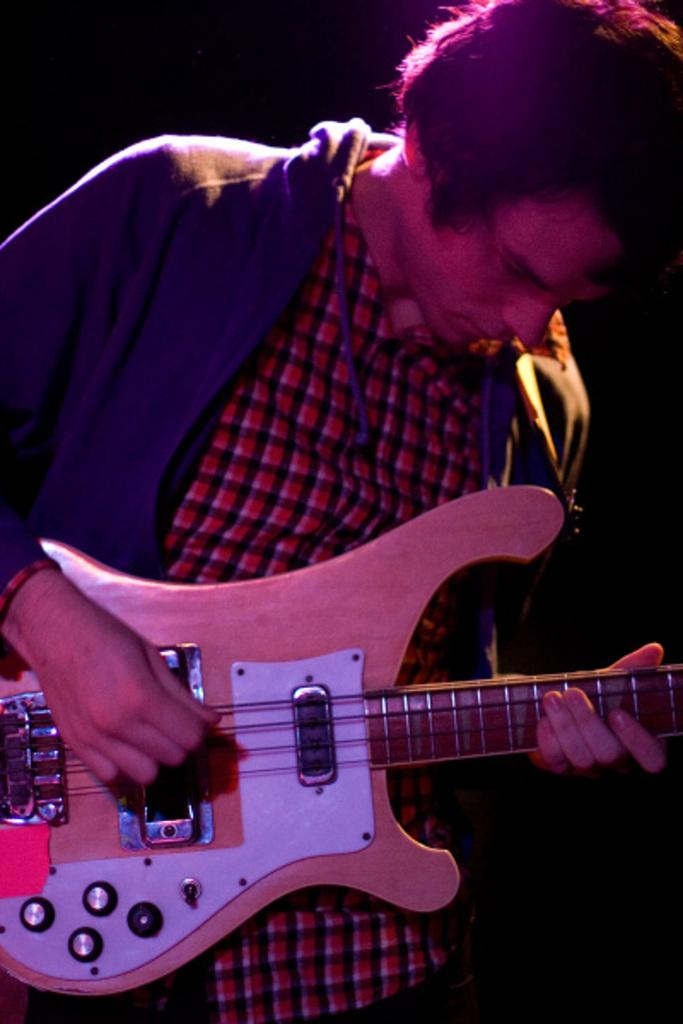What is the person in the image doing? The person in the image is playing a guitar. How is the person holding the guitar? The person is holding the guitar with both hands. What is the person wearing in the image? The person is wearing a blue color jacket. What direction is the person looking in the image? The person is looking downwards. Is there a woman holding a net in the image? No, there is no woman or net present in the image. The image features a person playing a guitar. 